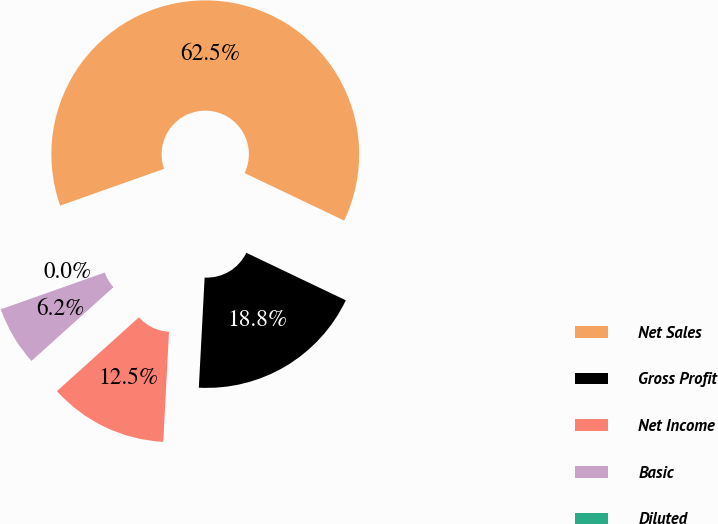Convert chart to OTSL. <chart><loc_0><loc_0><loc_500><loc_500><pie_chart><fcel>Net Sales<fcel>Gross Profit<fcel>Net Income<fcel>Basic<fcel>Diluted<nl><fcel>62.5%<fcel>18.75%<fcel>12.5%<fcel>6.25%<fcel>0.0%<nl></chart> 